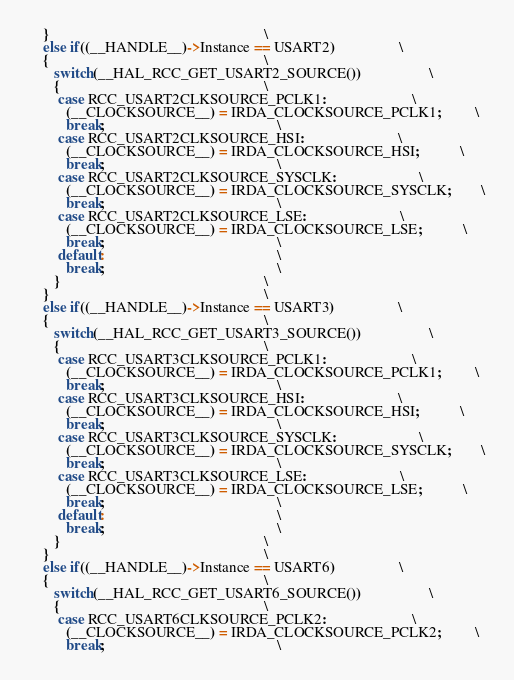Convert code to text. <code><loc_0><loc_0><loc_500><loc_500><_C_>    }                                                         \
    else if((__HANDLE__)->Instance == USART2)                 \
    {                                                         \
       switch(__HAL_RCC_GET_USART2_SOURCE())                  \
       {                                                      \
        case RCC_USART2CLKSOURCE_PCLK1:                       \
          (__CLOCKSOURCE__) = IRDA_CLOCKSOURCE_PCLK1;         \
          break;                                              \
        case RCC_USART2CLKSOURCE_HSI:                         \
          (__CLOCKSOURCE__) = IRDA_CLOCKSOURCE_HSI;           \
          break;                                              \
        case RCC_USART2CLKSOURCE_SYSCLK:                      \
          (__CLOCKSOURCE__) = IRDA_CLOCKSOURCE_SYSCLK;        \
          break;                                              \
        case RCC_USART2CLKSOURCE_LSE:                         \
          (__CLOCKSOURCE__) = IRDA_CLOCKSOURCE_LSE;           \
          break;                                              \
        default:                                              \
          break;                                              \
       }                                                      \
    }                                                         \
    else if((__HANDLE__)->Instance == USART3)                 \
    {                                                         \
       switch(__HAL_RCC_GET_USART3_SOURCE())                  \
       {                                                      \
        case RCC_USART3CLKSOURCE_PCLK1:                       \
          (__CLOCKSOURCE__) = IRDA_CLOCKSOURCE_PCLK1;         \
          break;                                              \
        case RCC_USART3CLKSOURCE_HSI:                         \
          (__CLOCKSOURCE__) = IRDA_CLOCKSOURCE_HSI;           \
          break;                                              \
        case RCC_USART3CLKSOURCE_SYSCLK:                      \
          (__CLOCKSOURCE__) = IRDA_CLOCKSOURCE_SYSCLK;        \
          break;                                              \
        case RCC_USART3CLKSOURCE_LSE:                         \
          (__CLOCKSOURCE__) = IRDA_CLOCKSOURCE_LSE;           \
          break;                                              \
        default:                                              \
          break;                                              \
       }                                                      \
    }                                                         \
    else if((__HANDLE__)->Instance == USART6)                 \
    {                                                         \
       switch(__HAL_RCC_GET_USART6_SOURCE())                  \
       {                                                      \
        case RCC_USART6CLKSOURCE_PCLK2:                       \
          (__CLOCKSOURCE__) = IRDA_CLOCKSOURCE_PCLK2;         \
          break;                                              \</code> 